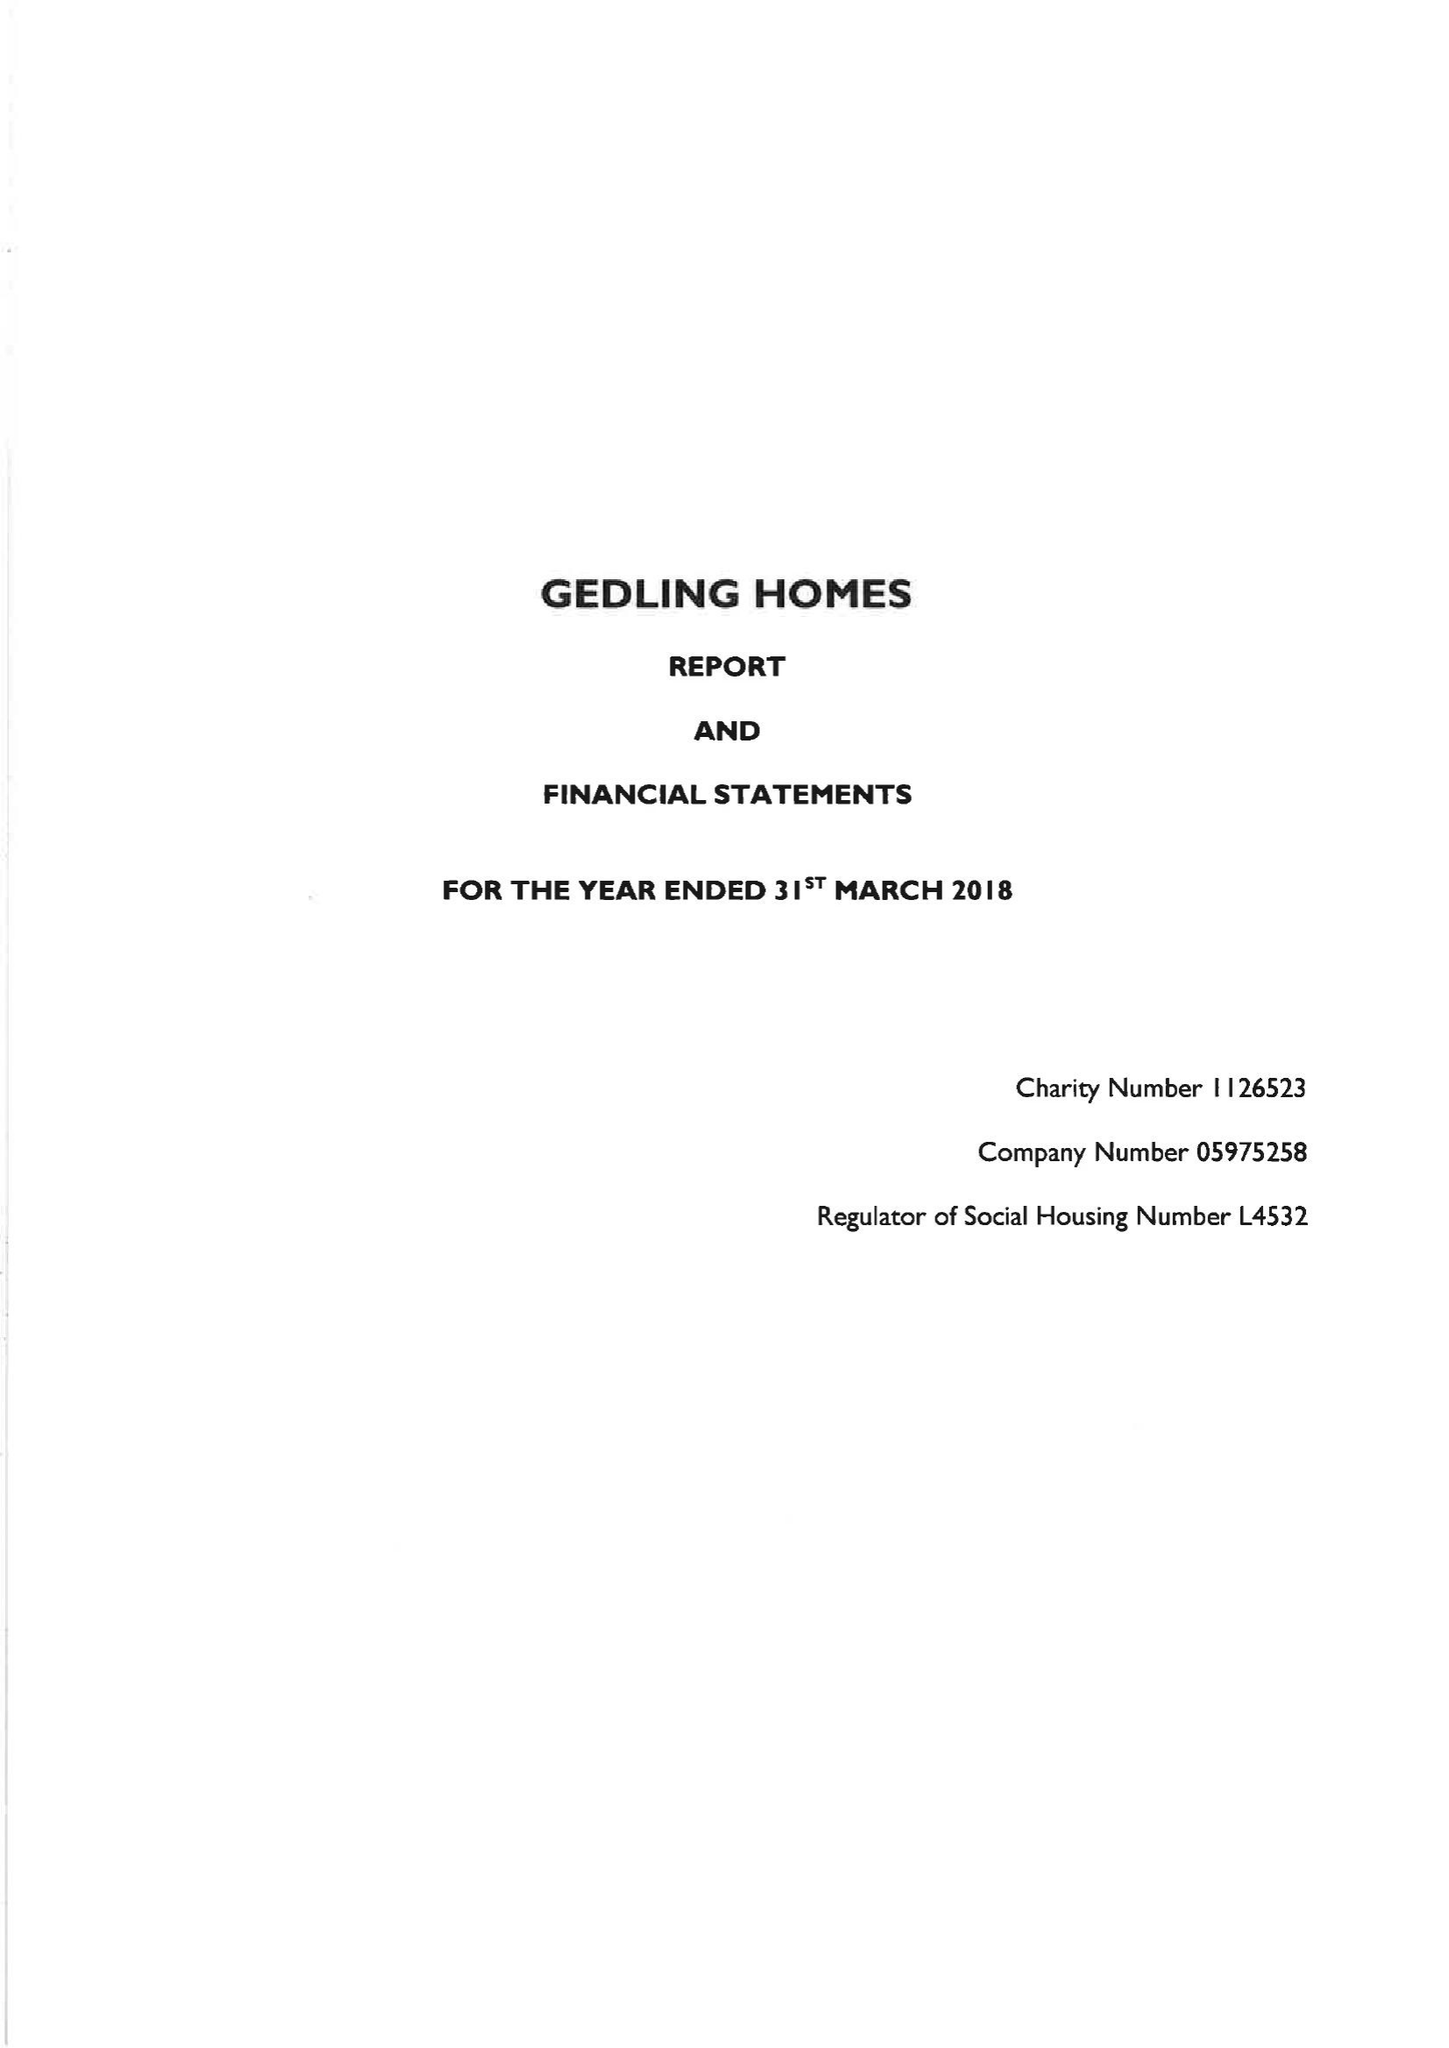What is the value for the income_annually_in_british_pounds?
Answer the question using a single word or phrase. 15909000.00 